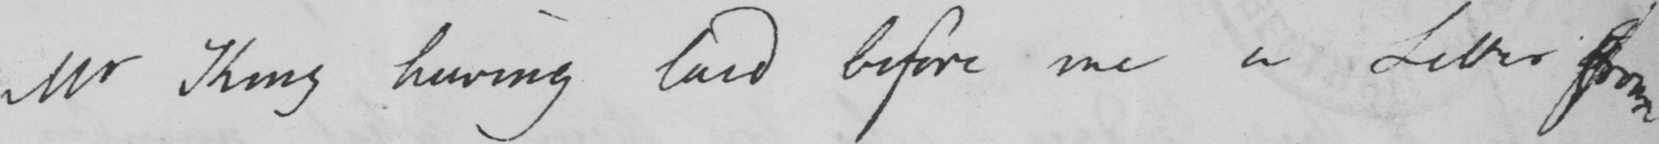Please provide the text content of this handwritten line. Mr King having laid before me a Letter from 